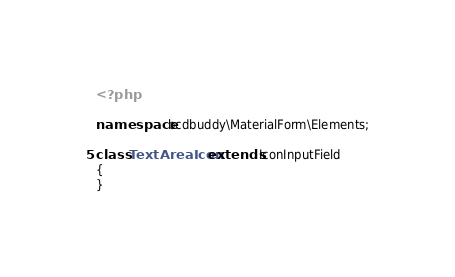Convert code to text. <code><loc_0><loc_0><loc_500><loc_500><_PHP_><?php

namespace bcdbuddy\MaterialForm\Elements;

class TextAreaIcon extends IconInputField
{
}</code> 